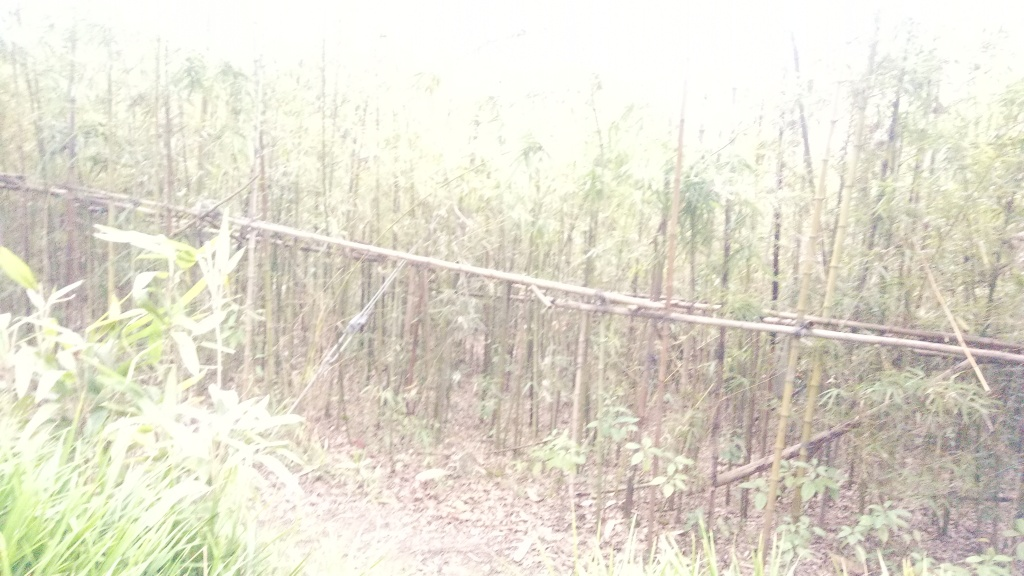Is this type of environment important for biodiversity? Yes, bamboo forests such as the one depicted in this image are important for biodiversity. They provide a unique ecosystem that supports a wide range of species, from pandas and insects to birds and smaller mammals. Bamboo is known for its rapid growth, making it an efficient carbon sink and a key resource that contributes to the livelihoods of various species as well as humans. 